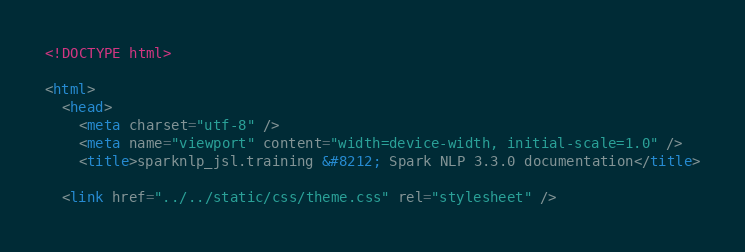<code> <loc_0><loc_0><loc_500><loc_500><_HTML_>
<!DOCTYPE html>

<html>
  <head>
    <meta charset="utf-8" />
    <meta name="viewport" content="width=device-width, initial-scale=1.0" />
    <title>sparknlp_jsl.training &#8212; Spark NLP 3.3.0 documentation</title>
    
  <link href="../../static/css/theme.css" rel="stylesheet" /></code> 